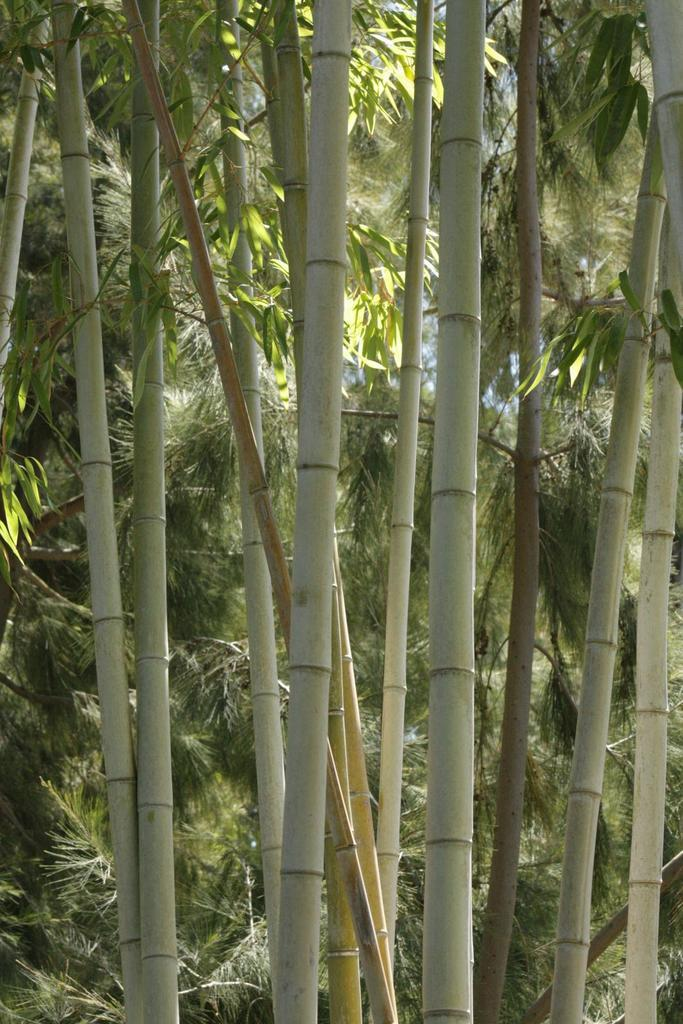What type of trees are in the image? There are bamboo trees in the image. Can you describe the background of the image? There are other trees visible in the background of the image. What type of brush can be seen in the image? There is no brush present in the image; it features bamboo trees and other trees in the background. 